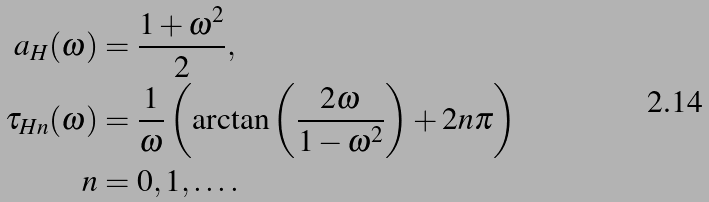<formula> <loc_0><loc_0><loc_500><loc_500>a _ { H } ( \omega ) & = \frac { 1 + \omega ^ { 2 } } { 2 } , \\ \tau _ { H n } ( \omega ) & = \frac { 1 } { \omega } \left ( \arctan \left ( \frac { 2 \omega } { 1 - \omega ^ { 2 } } \right ) + 2 n \pi \right ) \\ n & = 0 , 1 , \dots .</formula> 